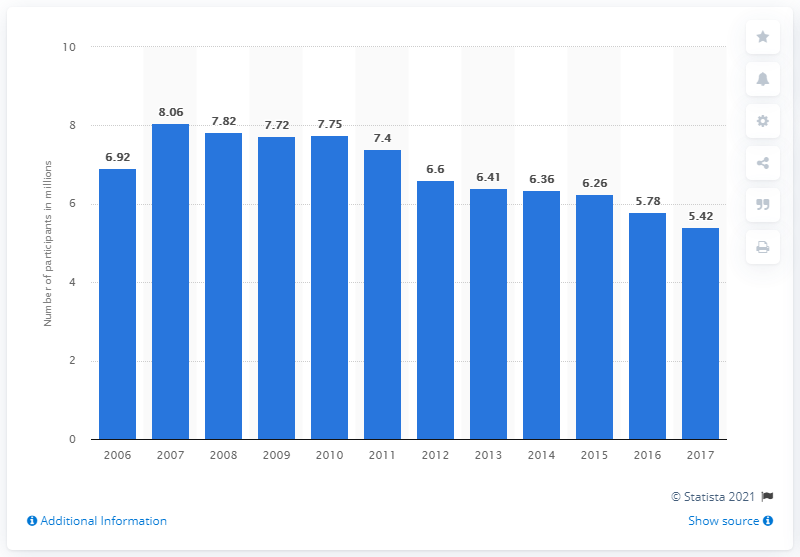Point out several critical features in this image. There were 5.42 participants in jet skiing in 2017. 